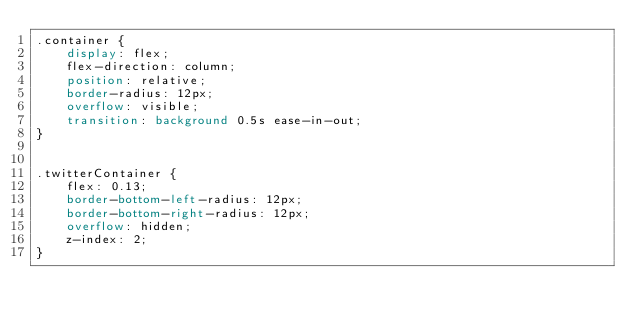<code> <loc_0><loc_0><loc_500><loc_500><_CSS_>.container {
    display: flex;
    flex-direction: column;
    position: relative;
    border-radius: 12px;
    overflow: visible;
    transition: background 0.5s ease-in-out;
}


.twitterContainer {
    flex: 0.13;
    border-bottom-left-radius: 12px;
    border-bottom-right-radius: 12px;
    overflow: hidden;
    z-index: 2;
}
</code> 